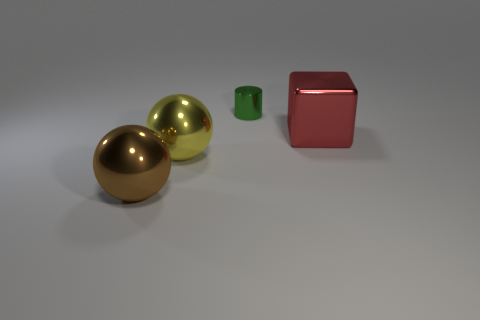Add 3 big green matte cylinders. How many objects exist? 7 Subtract all cylinders. How many objects are left? 3 Subtract all large purple matte blocks. Subtract all shiny balls. How many objects are left? 2 Add 2 metallic cylinders. How many metallic cylinders are left? 3 Add 4 small purple shiny cylinders. How many small purple shiny cylinders exist? 4 Subtract 0 purple balls. How many objects are left? 4 